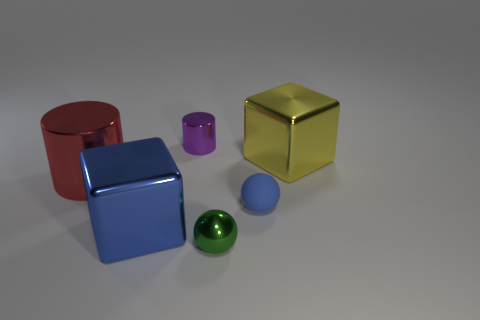Add 3 big gray shiny balls. How many objects exist? 9 Subtract all balls. How many objects are left? 4 Subtract all small blue rubber objects. Subtract all red shiny cylinders. How many objects are left? 4 Add 3 large blocks. How many large blocks are left? 5 Add 2 yellow balls. How many yellow balls exist? 2 Subtract 0 cyan cylinders. How many objects are left? 6 